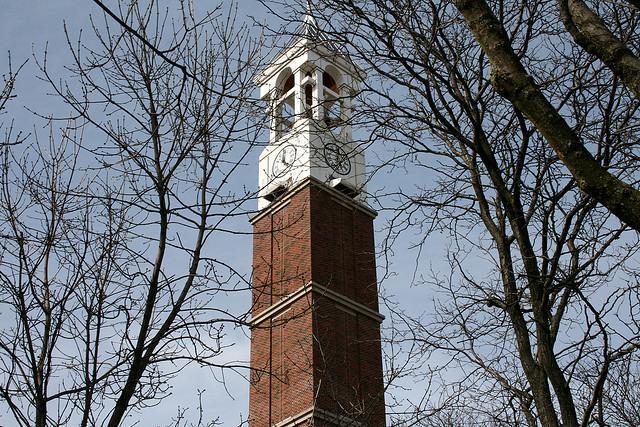How many men are wearing skis?
Give a very brief answer. 0. 